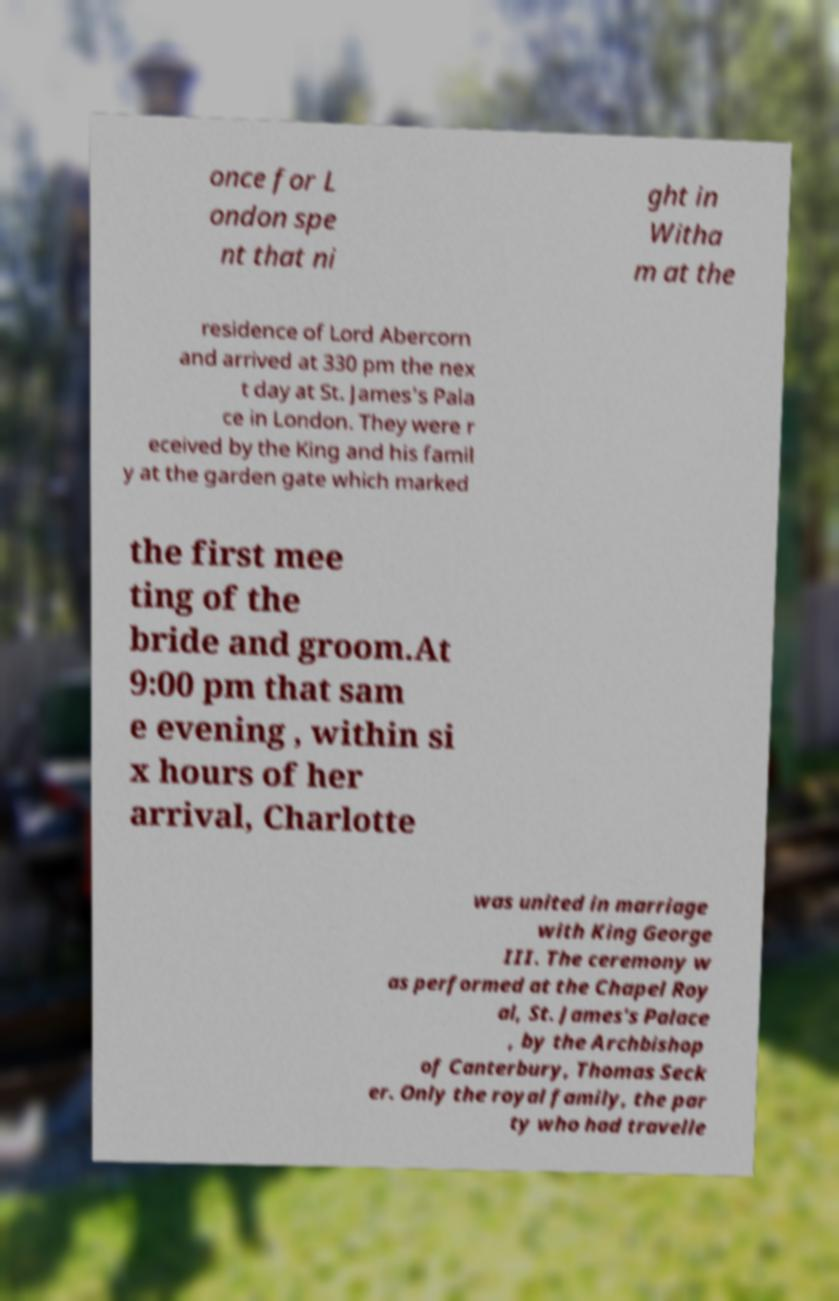I need the written content from this picture converted into text. Can you do that? once for L ondon spe nt that ni ght in Witha m at the residence of Lord Abercorn and arrived at 330 pm the nex t day at St. James's Pala ce in London. They were r eceived by the King and his famil y at the garden gate which marked the first mee ting of the bride and groom.At 9:00 pm that sam e evening , within si x hours of her arrival, Charlotte was united in marriage with King George III. The ceremony w as performed at the Chapel Roy al, St. James's Palace , by the Archbishop of Canterbury, Thomas Seck er. Only the royal family, the par ty who had travelle 